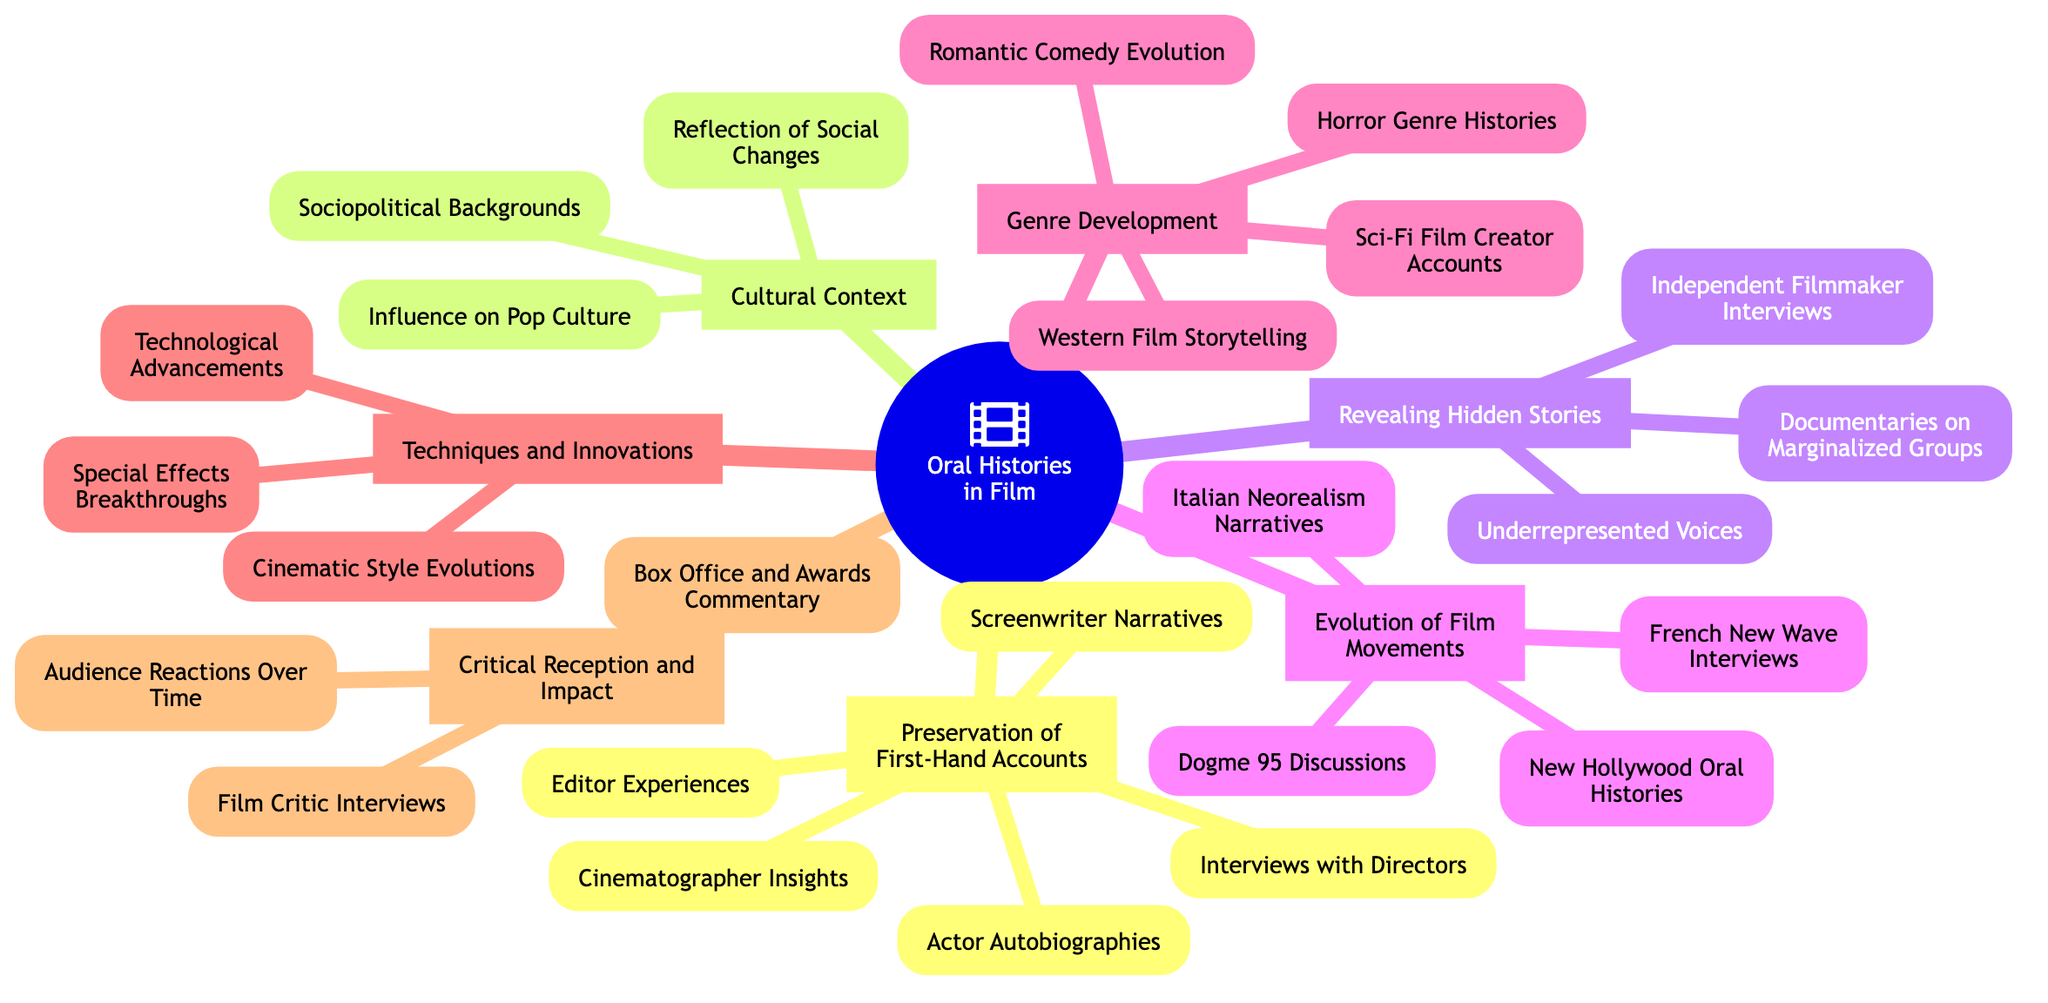What is the main topic of the mind map? The main topic is explicitly presented in the center of the mind map as "The Role of Oral Histories in Documenting Film Movements and Genres".
Answer: The Role of Oral Histories in Documenting Film Movements and Genres How many sub-topics are there? Counting the branches emerging from the main topic, there are a total of seven sub-topics listed around the main topic.
Answer: Seven Which sub-topic includes insights from cinematographers? The sub-topic that includes insights from cinematographers is "Preservation of First-Hand Accounts", which holds that specific component.
Answer: Preservation of First-Hand Accounts What is one component of the "Cultural Context" sub-topic? The sub-topic "Cultural Context" contains components such as "Sociopolitical Backgrounds", "Influence on Pop Culture", and "Reflection of Social Changes". Any one of these components can be provided as an answer.
Answer: Sociopolitical Backgrounds Which sub-topic addresses marginalized groups? The sub-topic addressing marginalized groups is "Revealing Hidden Stories", which explicitly mentions "Documentaries on Marginalized Groups" as one of its components.
Answer: Revealing Hidden Stories Which film movement has interviews documented in the mind map? Among the listed sub-topics, "Evolution of Film Movements" includes interviews related to several film movements, such as the French New Wave, making it the relevant answer.
Answer: Evolution of Film Movements What can be found in "Genre Development"? The sub-topic "Genre Development" features components detailing various genres, including "Sci-Fi Film Creator Accounts", "Horror Genre Histories", "Romantic Comedy Evolution", and "Western Film Storytelling". Any mentioned genre will suffice as an answer.
Answer: Sci-Fi Film Creator Accounts How many components are in "Techniques and Innovations"? The sub-topic "Techniques and Innovations" consists of three components: "Special Effects Breakthroughs", "Cinematic Style Evolutions", and "Technological Advancements". Therefore, the total number is three.
Answer: Three Which sub-topic involves audience reactions? The sub-topic that involves audience reactions is "Critical Reception and Impact", which directly includes "Audience Reactions Over Time" as a component.
Answer: Critical Reception and Impact 